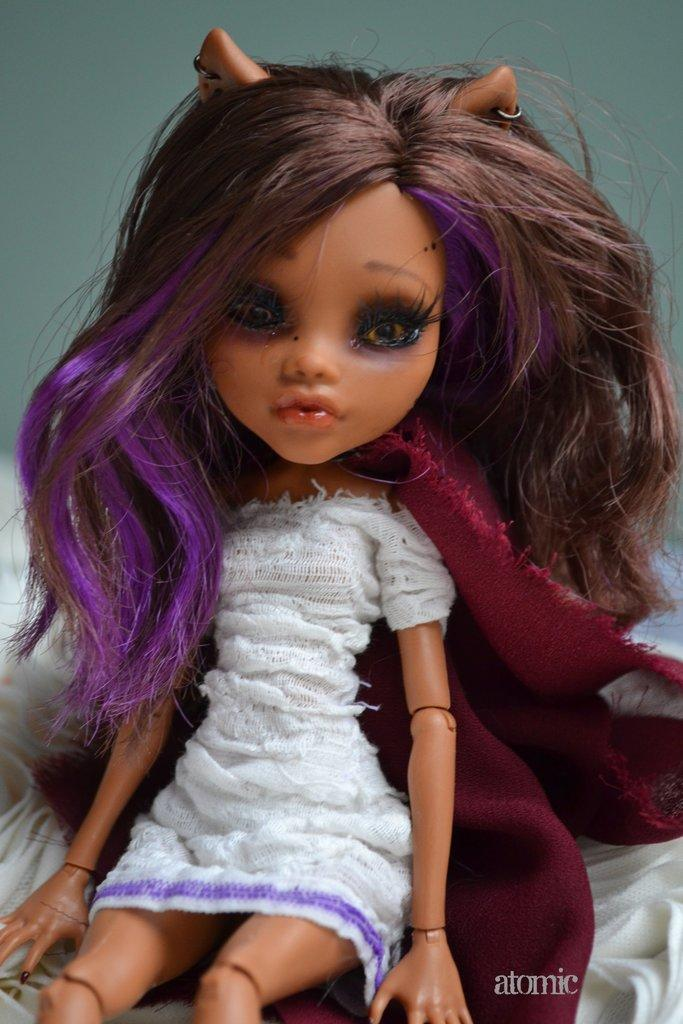What type of toy is depicted in the image? The toy is of a girl. What can be observed about the girl's attire in the image? The girl is wearing clothes. What type of bean is present in the image? There is no bean present in the image. What creature is depicted in the image? The image does not depict a creature; it features a toy of a girl. 